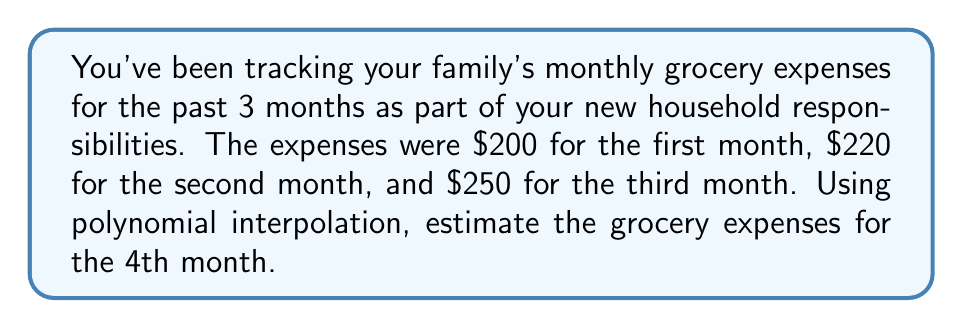What is the answer to this math problem? Let's approach this step-by-step using polynomial interpolation:

1) We have 3 data points: $(1, 200)$, $(2, 220)$, and $(3, 250)$.

2) We'll use a quadratic polynomial of the form $f(x) = ax^2 + bx + c$ to interpolate these points.

3) Substituting our data points into the equation:
   
   $200 = a(1)^2 + b(1) + c$
   $220 = a(2)^2 + b(2) + c$
   $250 = a(3)^2 + b(3) + c$

4) Simplifying:
   
   $200 = a + b + c$  (Equation 1)
   $220 = 4a + 2b + c$  (Equation 2)
   $250 = 9a + 3b + c$  (Equation 3)

5) Subtracting Equation 1 from Equation 2:
   $20 = 3a + b$  (Equation 4)

6) Subtracting Equation 1 from Equation 3:
   $50 = 8a + 2b$  (Equation 5)

7) Multiplying Equation 4 by 2 and subtracting from Equation 5:
   $10 = 2a$
   $a = 5$

8) Substituting $a = 5$ into Equation 4:
   $20 = 15 + b$
   $b = 5$

9) Substituting $a = 5$ and $b = 5$ into Equation 1:
   $200 = 5 + 5 + c$
   $c = 190$

10) Our interpolation polynomial is $f(x) = 5x^2 + 5x + 190$

11) To estimate the 4th month expenses, we evaluate $f(4)$:
    
    $f(4) = 5(4)^2 + 5(4) + 190 = 80 + 20 + 190 = 290$

Therefore, the estimated grocery expenses for the 4th month are $290.
Answer: $290 